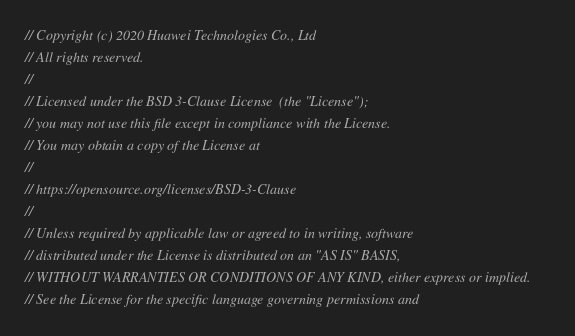<code> <loc_0><loc_0><loc_500><loc_500><_C_>// Copyright (c) 2020 Huawei Technologies Co., Ltd
// All rights reserved.
//
// Licensed under the BSD 3-Clause License  (the "License");
// you may not use this file except in compliance with the License.
// You may obtain a copy of the License at
//
// https://opensource.org/licenses/BSD-3-Clause
//
// Unless required by applicable law or agreed to in writing, software
// distributed under the License is distributed on an "AS IS" BASIS,
// WITHOUT WARRANTIES OR CONDITIONS OF ANY KIND, either express or implied.
// See the License for the specific language governing permissions and</code> 